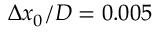<formula> <loc_0><loc_0><loc_500><loc_500>\Delta x _ { 0 } / D = 0 . 0 0 5</formula> 